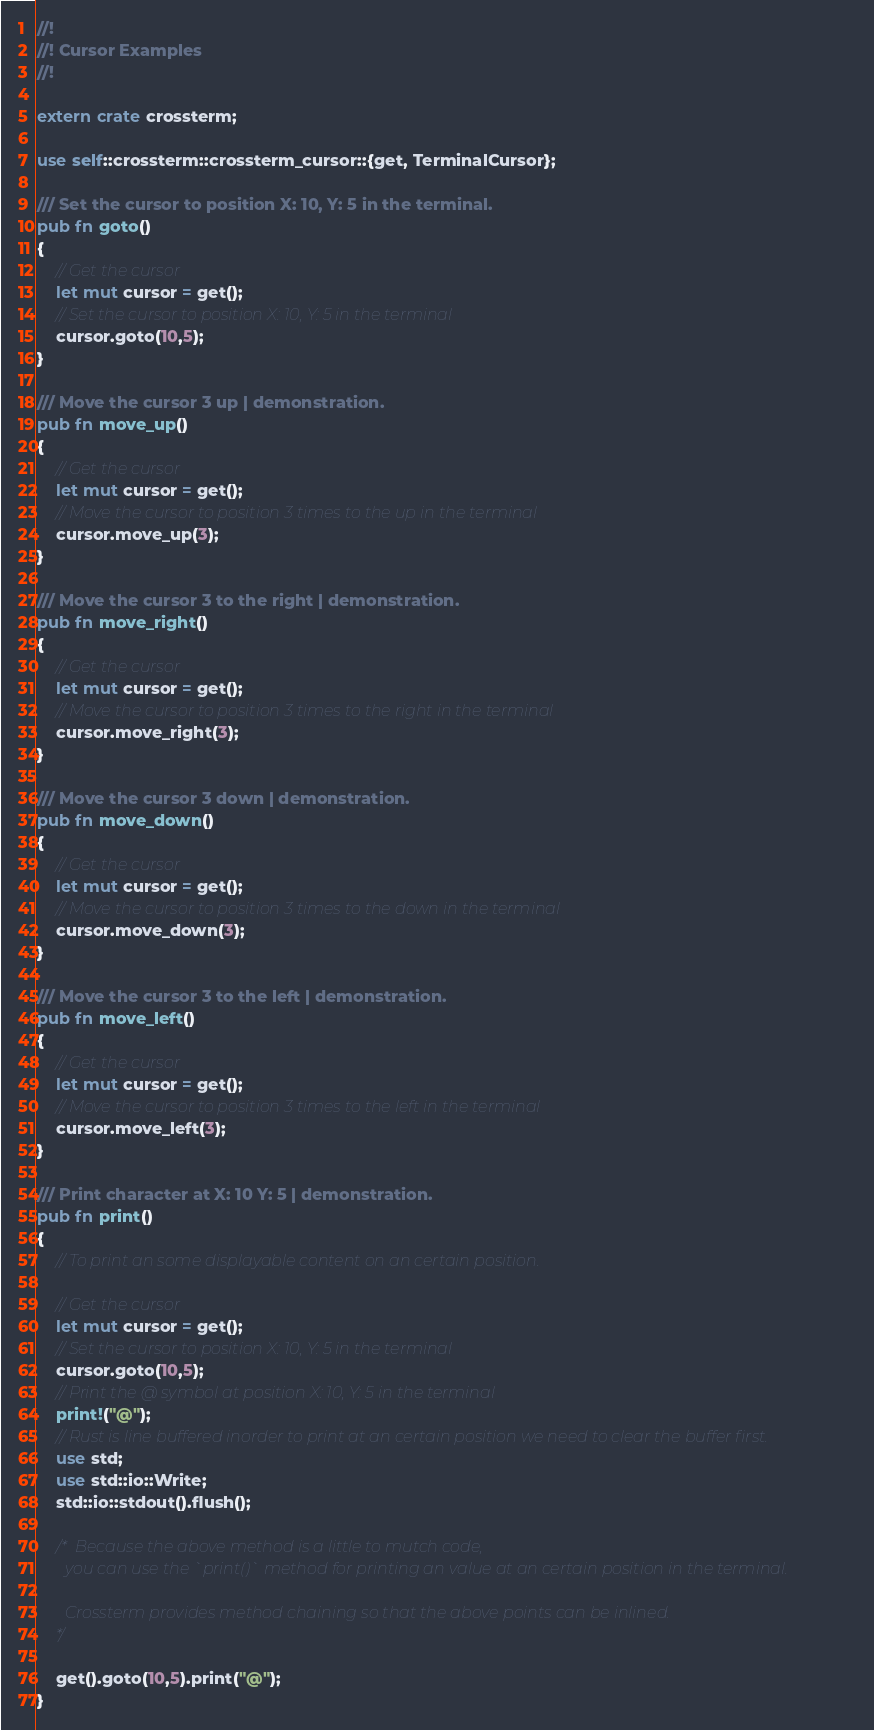<code> <loc_0><loc_0><loc_500><loc_500><_Rust_>//!    
//! Cursor Examples
//!

extern crate crossterm;

use self::crossterm::crossterm_cursor::{get, TerminalCursor};

/// Set the cursor to position X: 10, Y: 5 in the terminal.
pub fn goto()
{
    // Get the cursor
    let mut cursor = get();
    // Set the cursor to position X: 10, Y: 5 in the terminal
    cursor.goto(10,5);    
}

/// Move the cursor 3 up | demonstration.
pub fn move_up()
{
    // Get the cursor
    let mut cursor = get();
    // Move the cursor to position 3 times to the up in the terminal
    cursor.move_up(3);
}

/// Move the cursor 3 to the right | demonstration.
pub fn move_right()
{
    // Get the cursor
    let mut cursor = get();
    // Move the cursor to position 3 times to the right in the terminal
    cursor.move_right(3);
}

/// Move the cursor 3 down | demonstration.
pub fn move_down()
{
    // Get the cursor
    let mut cursor = get();
    // Move the cursor to position 3 times to the down in the terminal
    cursor.move_down(3);
}

/// Move the cursor 3 to the left | demonstration.
pub fn move_left()
{
    // Get the cursor
    let mut cursor = get();
    // Move the cursor to position 3 times to the left in the terminal
    cursor.move_left(3);
}

/// Print character at X: 10 Y: 5 | demonstration.
pub fn print()
{
    // To print an some displayable content on an certain position.  
    
    // Get the cursor
    let mut cursor = get();
    // Set the cursor to position X: 10, Y: 5 in the terminal
    cursor.goto(10,5);
    // Print the @ symbol at position X: 10, Y: 5 in the terminal
    print!("@");
    // Rust is line buffered inorder to print at an certain position we need to clear the buffer first. 
    use std;
    use std::io::Write;
    std::io::stdout().flush();
    
    /* Because the above method is a little to mutch code, 
       you can use the `print()` method for printing an value at an certain position in the terminal.
       
       Crossterm provides method chaining so that the above points can be inlined.
    */
    
    get().goto(10,5).print("@");    
}





















</code> 